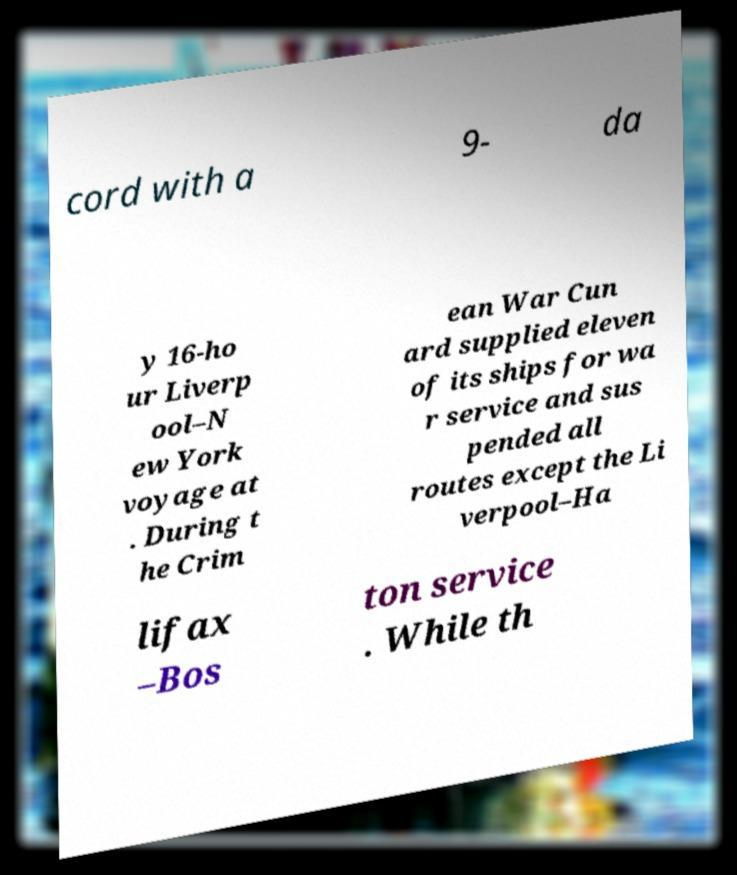For documentation purposes, I need the text within this image transcribed. Could you provide that? cord with a 9- da y 16-ho ur Liverp ool–N ew York voyage at . During t he Crim ean War Cun ard supplied eleven of its ships for wa r service and sus pended all routes except the Li verpool–Ha lifax –Bos ton service . While th 